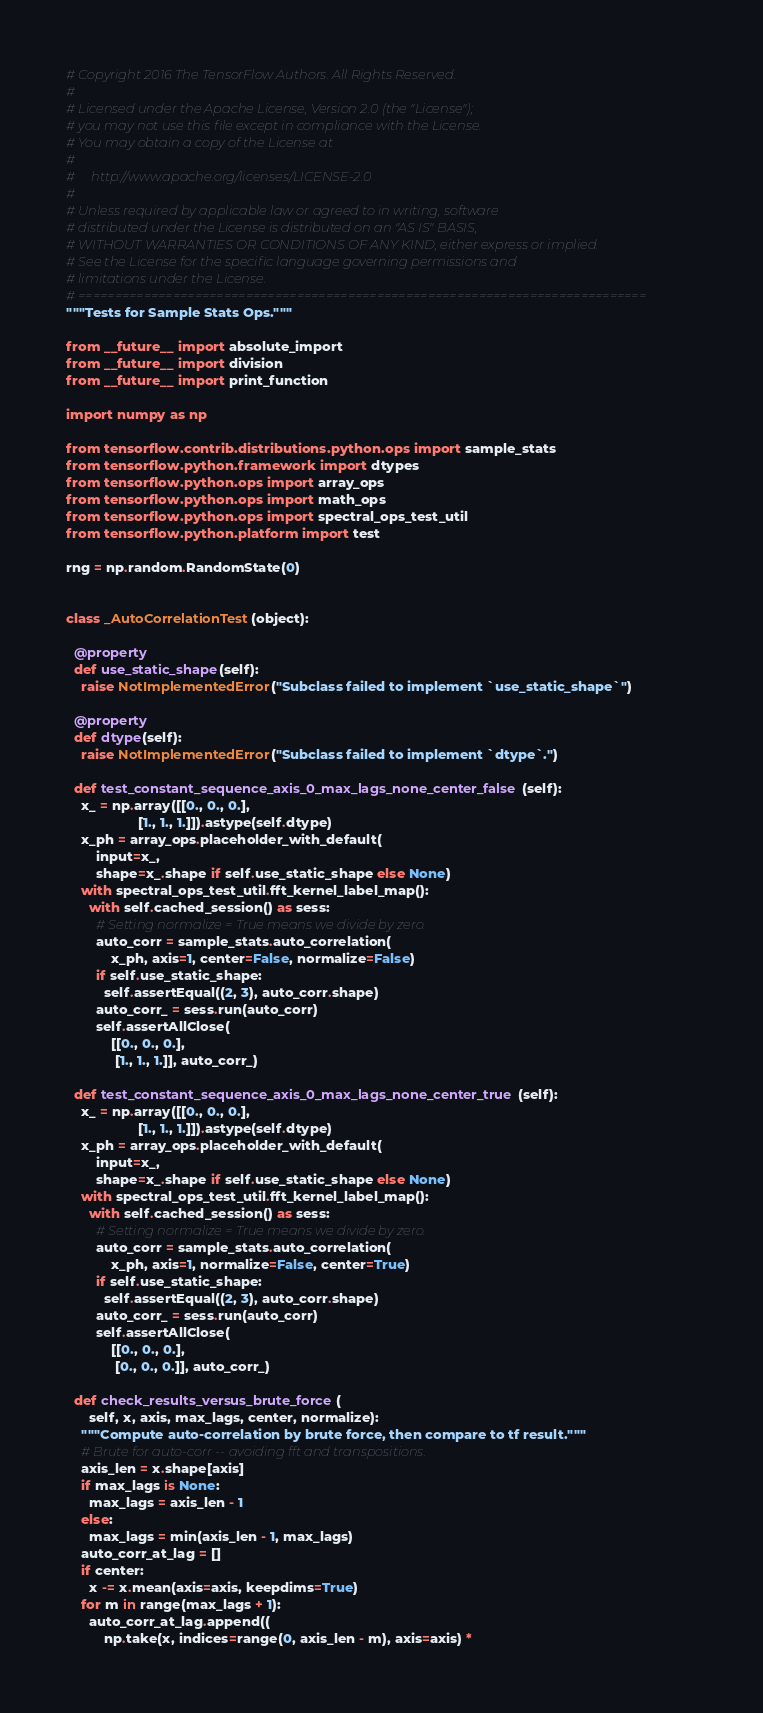Convert code to text. <code><loc_0><loc_0><loc_500><loc_500><_Python_># Copyright 2016 The TensorFlow Authors. All Rights Reserved.
#
# Licensed under the Apache License, Version 2.0 (the "License");
# you may not use this file except in compliance with the License.
# You may obtain a copy of the License at
#
#     http://www.apache.org/licenses/LICENSE-2.0
#
# Unless required by applicable law or agreed to in writing, software
# distributed under the License is distributed on an "AS IS" BASIS,
# WITHOUT WARRANTIES OR CONDITIONS OF ANY KIND, either express or implied.
# See the License for the specific language governing permissions and
# limitations under the License.
# ==============================================================================
"""Tests for Sample Stats Ops."""

from __future__ import absolute_import
from __future__ import division
from __future__ import print_function

import numpy as np

from tensorflow.contrib.distributions.python.ops import sample_stats
from tensorflow.python.framework import dtypes
from tensorflow.python.ops import array_ops
from tensorflow.python.ops import math_ops
from tensorflow.python.ops import spectral_ops_test_util
from tensorflow.python.platform import test

rng = np.random.RandomState(0)


class _AutoCorrelationTest(object):

  @property
  def use_static_shape(self):
    raise NotImplementedError("Subclass failed to implement `use_static_shape`")

  @property
  def dtype(self):
    raise NotImplementedError("Subclass failed to implement `dtype`.")

  def test_constant_sequence_axis_0_max_lags_none_center_false(self):
    x_ = np.array([[0., 0., 0.],
                   [1., 1., 1.]]).astype(self.dtype)
    x_ph = array_ops.placeholder_with_default(
        input=x_,
        shape=x_.shape if self.use_static_shape else None)
    with spectral_ops_test_util.fft_kernel_label_map():
      with self.cached_session() as sess:
        # Setting normalize = True means we divide by zero.
        auto_corr = sample_stats.auto_correlation(
            x_ph, axis=1, center=False, normalize=False)
        if self.use_static_shape:
          self.assertEqual((2, 3), auto_corr.shape)
        auto_corr_ = sess.run(auto_corr)
        self.assertAllClose(
            [[0., 0., 0.],
             [1., 1., 1.]], auto_corr_)

  def test_constant_sequence_axis_0_max_lags_none_center_true(self):
    x_ = np.array([[0., 0., 0.],
                   [1., 1., 1.]]).astype(self.dtype)
    x_ph = array_ops.placeholder_with_default(
        input=x_,
        shape=x_.shape if self.use_static_shape else None)
    with spectral_ops_test_util.fft_kernel_label_map():
      with self.cached_session() as sess:
        # Setting normalize = True means we divide by zero.
        auto_corr = sample_stats.auto_correlation(
            x_ph, axis=1, normalize=False, center=True)
        if self.use_static_shape:
          self.assertEqual((2, 3), auto_corr.shape)
        auto_corr_ = sess.run(auto_corr)
        self.assertAllClose(
            [[0., 0., 0.],
             [0., 0., 0.]], auto_corr_)

  def check_results_versus_brute_force(
      self, x, axis, max_lags, center, normalize):
    """Compute auto-correlation by brute force, then compare to tf result."""
    # Brute for auto-corr -- avoiding fft and transpositions.
    axis_len = x.shape[axis]
    if max_lags is None:
      max_lags = axis_len - 1
    else:
      max_lags = min(axis_len - 1, max_lags)
    auto_corr_at_lag = []
    if center:
      x -= x.mean(axis=axis, keepdims=True)
    for m in range(max_lags + 1):
      auto_corr_at_lag.append((
          np.take(x, indices=range(0, axis_len - m), axis=axis) *</code> 